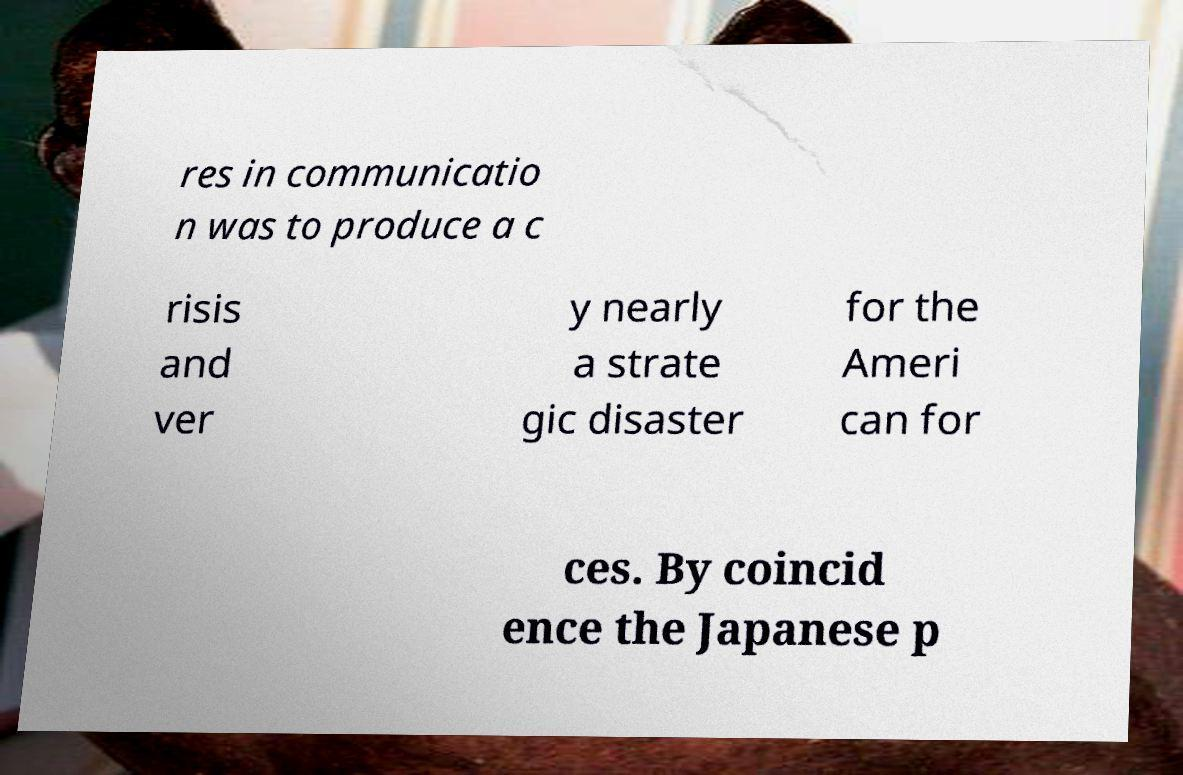Please identify and transcribe the text found in this image. res in communicatio n was to produce a c risis and ver y nearly a strate gic disaster for the Ameri can for ces. By coincid ence the Japanese p 